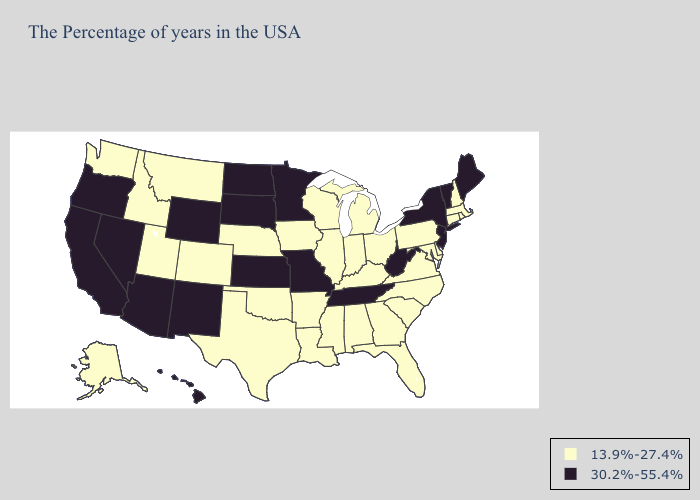Does the map have missing data?
Write a very short answer. No. Does Wisconsin have the highest value in the USA?
Be succinct. No. Name the states that have a value in the range 30.2%-55.4%?
Write a very short answer. Maine, Vermont, New York, New Jersey, West Virginia, Tennessee, Missouri, Minnesota, Kansas, South Dakota, North Dakota, Wyoming, New Mexico, Arizona, Nevada, California, Oregon, Hawaii. Name the states that have a value in the range 30.2%-55.4%?
Quick response, please. Maine, Vermont, New York, New Jersey, West Virginia, Tennessee, Missouri, Minnesota, Kansas, South Dakota, North Dakota, Wyoming, New Mexico, Arizona, Nevada, California, Oregon, Hawaii. Does Pennsylvania have the highest value in the Northeast?
Short answer required. No. What is the value of Florida?
Quick response, please. 13.9%-27.4%. Name the states that have a value in the range 30.2%-55.4%?
Keep it brief. Maine, Vermont, New York, New Jersey, West Virginia, Tennessee, Missouri, Minnesota, Kansas, South Dakota, North Dakota, Wyoming, New Mexico, Arizona, Nevada, California, Oregon, Hawaii. What is the value of South Dakota?
Short answer required. 30.2%-55.4%. Does Illinois have the highest value in the MidWest?
Answer briefly. No. Does West Virginia have the highest value in the USA?
Quick response, please. Yes. Among the states that border New Hampshire , does Massachusetts have the lowest value?
Be succinct. Yes. How many symbols are there in the legend?
Keep it brief. 2. What is the lowest value in states that border Arizona?
Concise answer only. 13.9%-27.4%. 